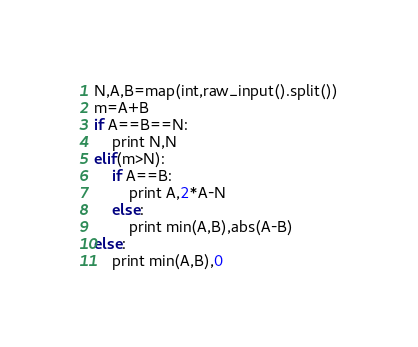<code> <loc_0><loc_0><loc_500><loc_500><_Python_>N,A,B=map(int,raw_input().split())
m=A+B
if A==B==N:
	print N,N
elif(m>N):
	if A==B:
		print A,2*A-N
	else:
		print min(A,B),abs(A-B)
else:
	print min(A,B),0


</code> 